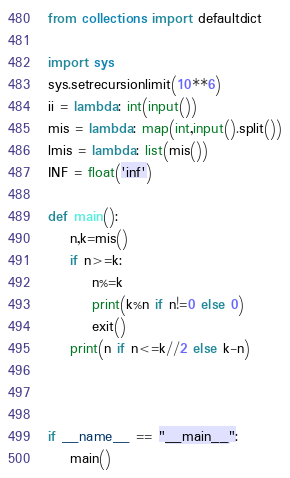<code> <loc_0><loc_0><loc_500><loc_500><_Python_>from collections import defaultdict

import sys
sys.setrecursionlimit(10**6)
ii = lambda: int(input())
mis = lambda: map(int,input().split())
lmis = lambda: list(mis())
INF = float('inf')

def main():
    n,k=mis()
    if n>=k:
        n%=k
        print(k%n if n!=0 else 0)
        exit()    
    print(n if n<=k//2 else k-n)



if __name__ == "__main__":
    main()</code> 